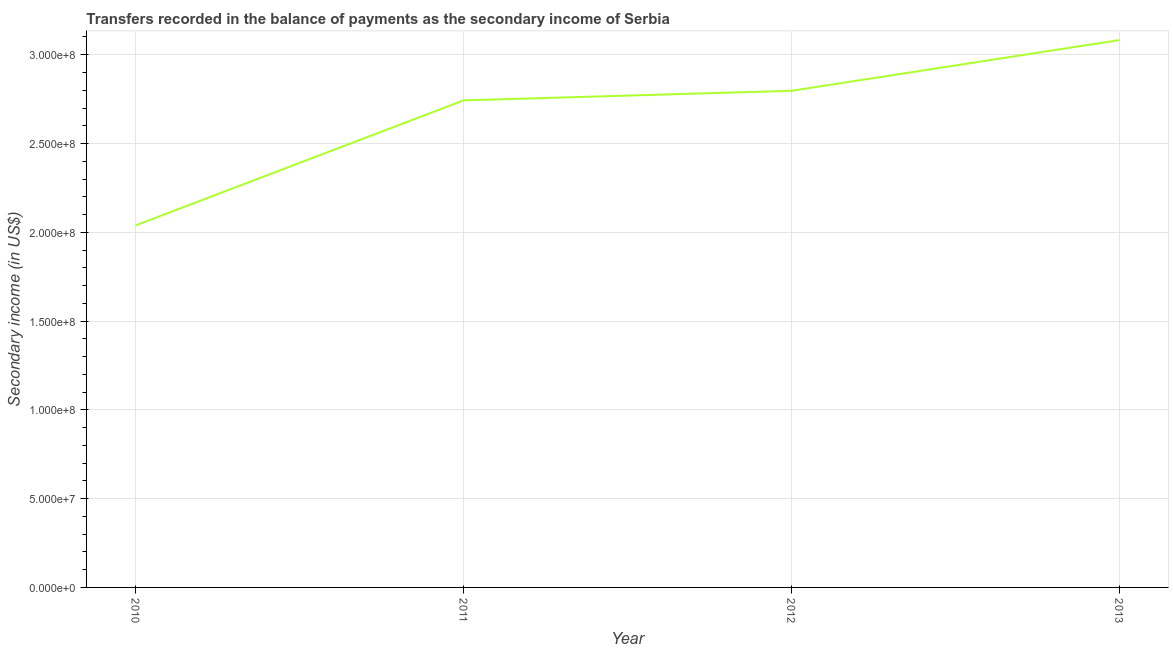What is the amount of secondary income in 2012?
Provide a succinct answer. 2.80e+08. Across all years, what is the maximum amount of secondary income?
Ensure brevity in your answer.  3.08e+08. Across all years, what is the minimum amount of secondary income?
Ensure brevity in your answer.  2.04e+08. What is the sum of the amount of secondary income?
Provide a short and direct response. 1.07e+09. What is the difference between the amount of secondary income in 2010 and 2013?
Make the answer very short. -1.04e+08. What is the average amount of secondary income per year?
Provide a succinct answer. 2.67e+08. What is the median amount of secondary income?
Your answer should be very brief. 2.77e+08. Do a majority of the years between 2013 and 2011 (inclusive) have amount of secondary income greater than 160000000 US$?
Your answer should be very brief. No. What is the ratio of the amount of secondary income in 2011 to that in 2013?
Your answer should be very brief. 0.89. Is the amount of secondary income in 2011 less than that in 2013?
Make the answer very short. Yes. Is the difference between the amount of secondary income in 2010 and 2012 greater than the difference between any two years?
Offer a very short reply. No. What is the difference between the highest and the second highest amount of secondary income?
Your answer should be very brief. 2.86e+07. What is the difference between the highest and the lowest amount of secondary income?
Offer a very short reply. 1.04e+08. In how many years, is the amount of secondary income greater than the average amount of secondary income taken over all years?
Keep it short and to the point. 3. Does the amount of secondary income monotonically increase over the years?
Make the answer very short. Yes. How many years are there in the graph?
Give a very brief answer. 4. What is the difference between two consecutive major ticks on the Y-axis?
Offer a very short reply. 5.00e+07. Does the graph contain grids?
Your answer should be compact. Yes. What is the title of the graph?
Provide a short and direct response. Transfers recorded in the balance of payments as the secondary income of Serbia. What is the label or title of the Y-axis?
Give a very brief answer. Secondary income (in US$). What is the Secondary income (in US$) of 2010?
Provide a short and direct response. 2.04e+08. What is the Secondary income (in US$) in 2011?
Offer a very short reply. 2.74e+08. What is the Secondary income (in US$) in 2012?
Offer a terse response. 2.80e+08. What is the Secondary income (in US$) of 2013?
Keep it short and to the point. 3.08e+08. What is the difference between the Secondary income (in US$) in 2010 and 2011?
Ensure brevity in your answer.  -7.04e+07. What is the difference between the Secondary income (in US$) in 2010 and 2012?
Provide a succinct answer. -7.58e+07. What is the difference between the Secondary income (in US$) in 2010 and 2013?
Give a very brief answer. -1.04e+08. What is the difference between the Secondary income (in US$) in 2011 and 2012?
Your answer should be compact. -5.39e+06. What is the difference between the Secondary income (in US$) in 2011 and 2013?
Give a very brief answer. -3.40e+07. What is the difference between the Secondary income (in US$) in 2012 and 2013?
Provide a succinct answer. -2.86e+07. What is the ratio of the Secondary income (in US$) in 2010 to that in 2011?
Offer a terse response. 0.74. What is the ratio of the Secondary income (in US$) in 2010 to that in 2012?
Provide a short and direct response. 0.73. What is the ratio of the Secondary income (in US$) in 2010 to that in 2013?
Keep it short and to the point. 0.66. What is the ratio of the Secondary income (in US$) in 2011 to that in 2012?
Provide a short and direct response. 0.98. What is the ratio of the Secondary income (in US$) in 2011 to that in 2013?
Your answer should be compact. 0.89. What is the ratio of the Secondary income (in US$) in 2012 to that in 2013?
Your response must be concise. 0.91. 